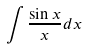<formula> <loc_0><loc_0><loc_500><loc_500>\int \frac { \sin x } { x } d x</formula> 